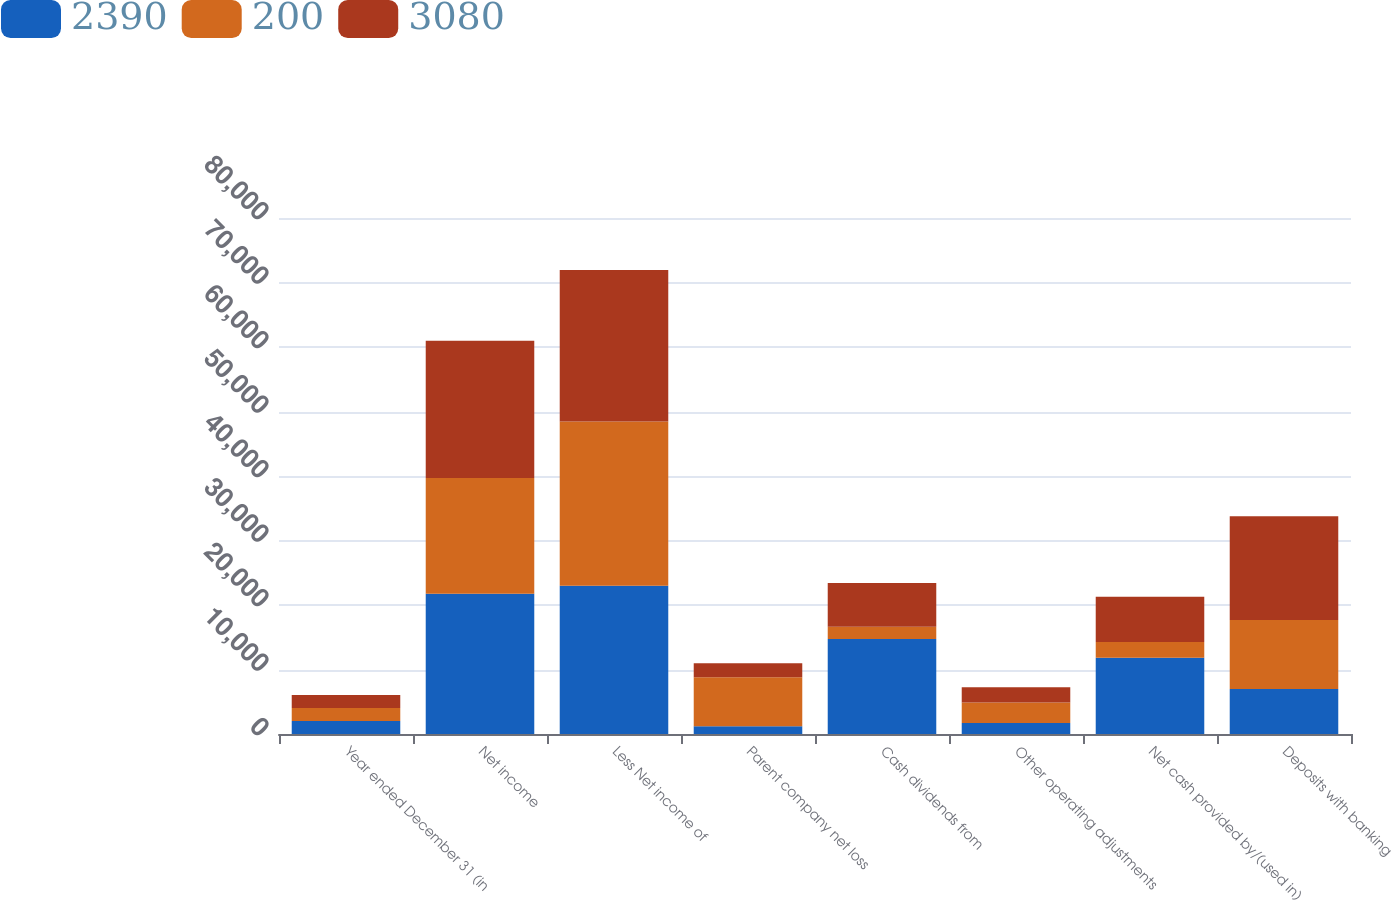Convert chart. <chart><loc_0><loc_0><loc_500><loc_500><stacked_bar_chart><ecel><fcel>Year ended December 31 (in<fcel>Net income<fcel>Less Net income of<fcel>Parent company net loss<fcel>Cash dividends from<fcel>Other operating adjustments<fcel>Net cash provided by/(used in)<fcel>Deposits with banking<nl><fcel>2390<fcel>2014<fcel>21762<fcel>22972<fcel>1210<fcel>14714<fcel>1698<fcel>11806<fcel>6984<nl><fcel>200<fcel>2013<fcel>17923<fcel>25496<fcel>7573<fcel>1917<fcel>3180<fcel>2476<fcel>10679<nl><fcel>3080<fcel>2012<fcel>21284<fcel>23474<fcel>2190<fcel>6798<fcel>2376<fcel>6984<fcel>16100<nl></chart> 